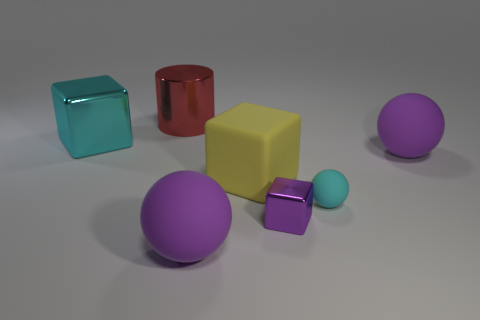How does the lighting in the image affect the perception of the objects? The lighting in the image is relatively soft and diffused, allowing for clear visibility of the objects’ colors and shapes without creating harsh shadows. It enhances the three-dimensionality of the objects, revealing the textures and contributing to the overall serene and balanced composition of the scene. 